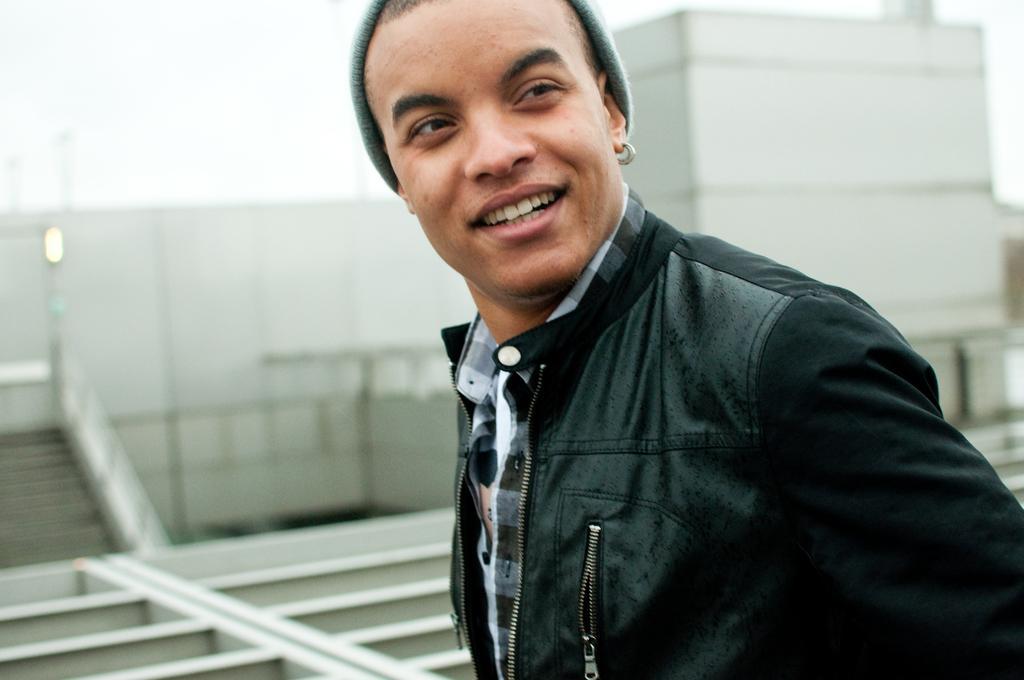Can you describe this image briefly? In this picture we can see stairs. A man is wearing a black jacket and smiling. 